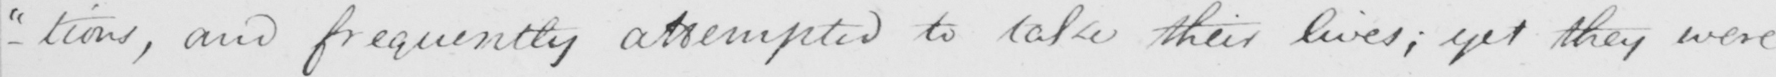Can you tell me what this handwritten text says? -"tions, "and frequently attempted to take their lives; yet they were 